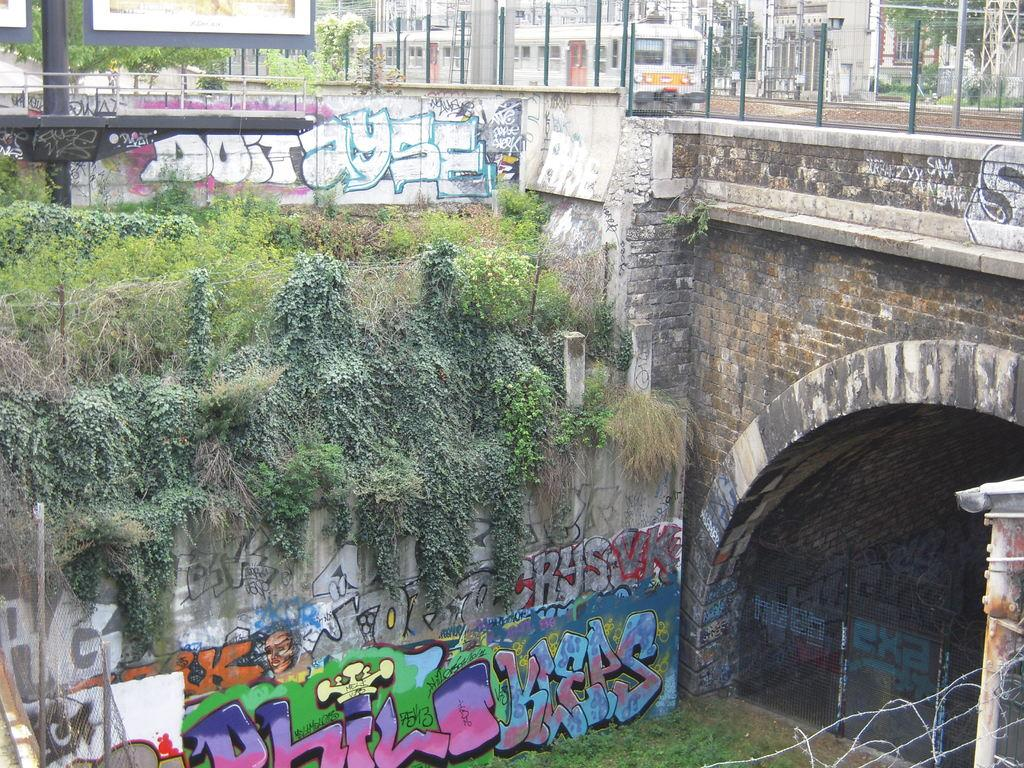What is the main subject of the image? The main subject of the image is a train. What other objects can be seen in the image? There are iron poles, a wall with text, plants, a fence, and buildings in the background of the image. How many clocks are visible in the image? There are no clocks present in the image. What type of books can be found in the library depicted in the image? There is no library depicted in the image. 